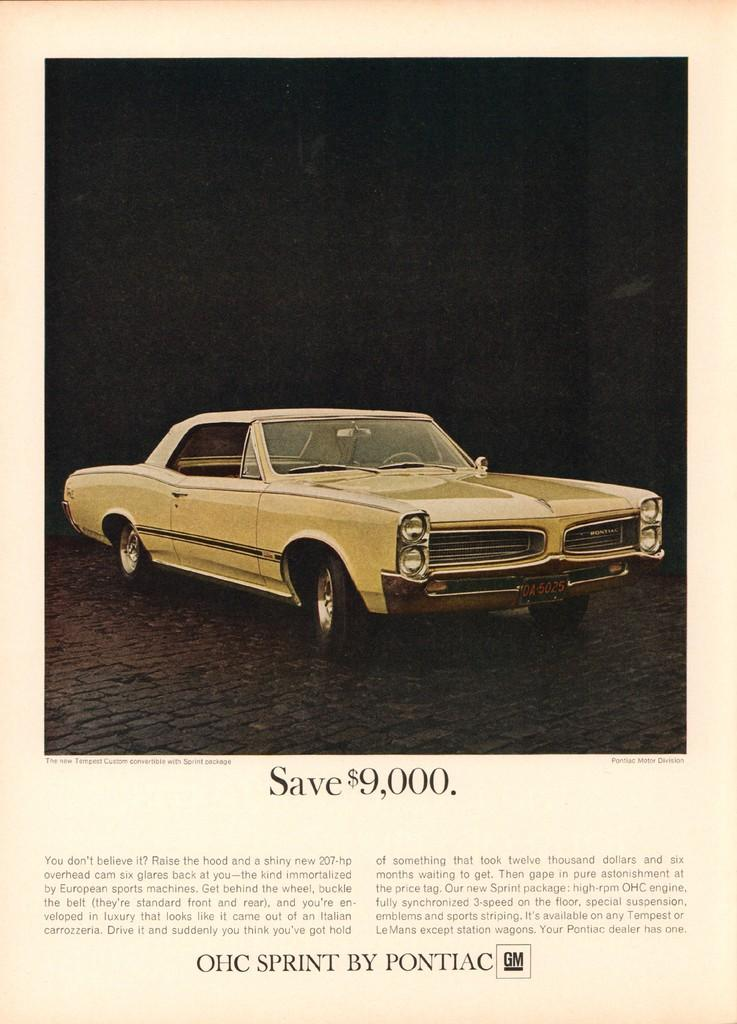What type of medium is the image taken from? The image is a page from a book. What is shown on the page? There is a vehicle depicted on the page. What else can be found on the page? Text is present on the page. What type of eye can be seen on the vehicle in the image? There is no eye present on the vehicle in the image. What religion is depicted in the image? The image does not depict any religious symbols or themes. 